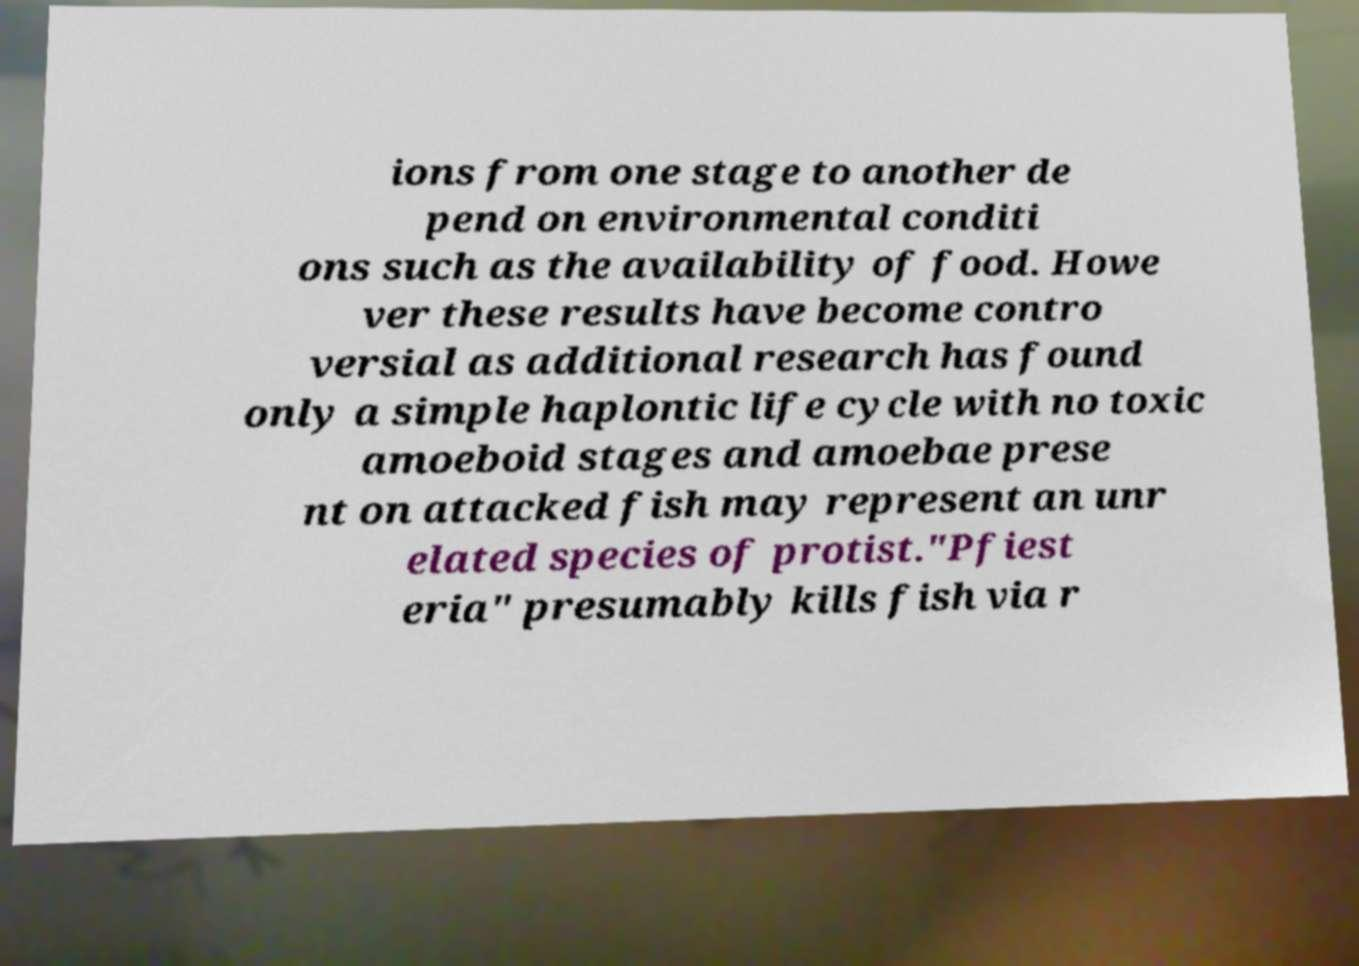I need the written content from this picture converted into text. Can you do that? ions from one stage to another de pend on environmental conditi ons such as the availability of food. Howe ver these results have become contro versial as additional research has found only a simple haplontic life cycle with no toxic amoeboid stages and amoebae prese nt on attacked fish may represent an unr elated species of protist."Pfiest eria" presumably kills fish via r 